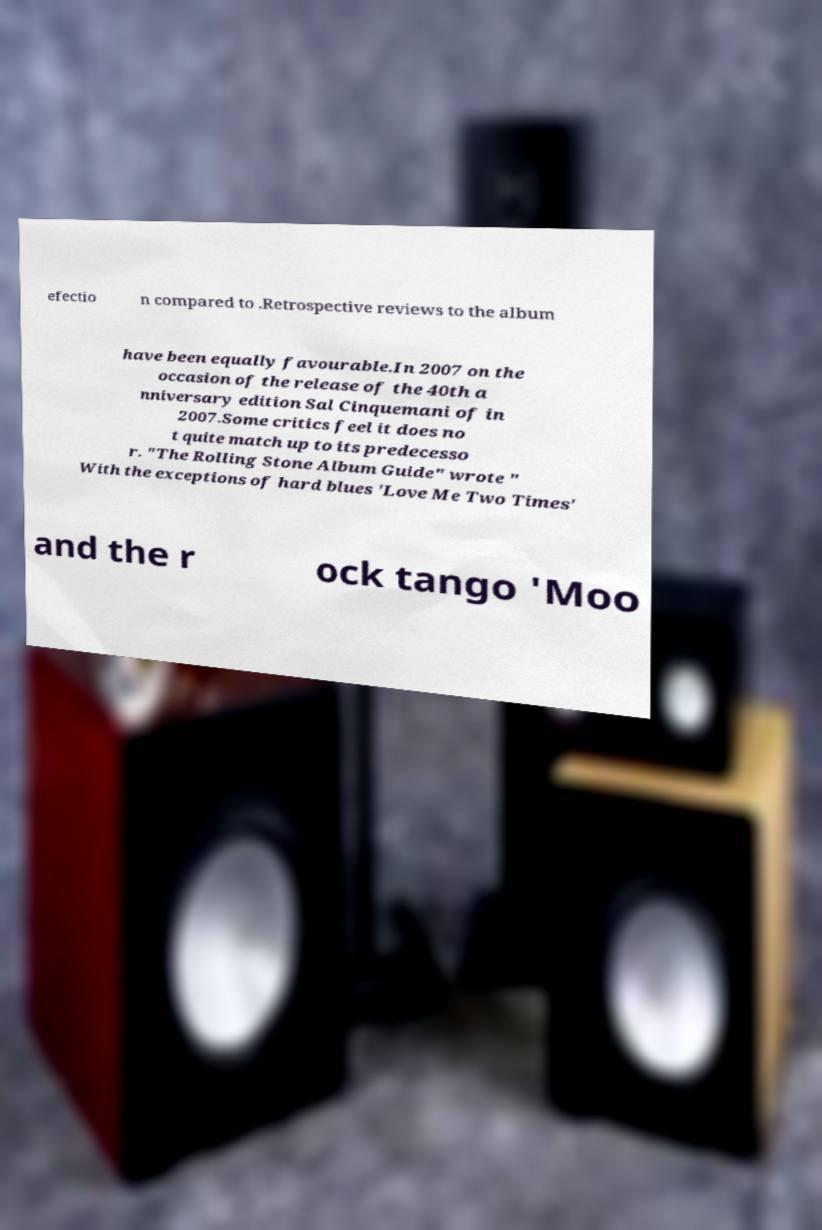Can you read and provide the text displayed in the image?This photo seems to have some interesting text. Can you extract and type it out for me? efectio n compared to .Retrospective reviews to the album have been equally favourable.In 2007 on the occasion of the release of the 40th a nniversary edition Sal Cinquemani of in 2007.Some critics feel it does no t quite match up to its predecesso r. "The Rolling Stone Album Guide" wrote " With the exceptions of hard blues 'Love Me Two Times' and the r ock tango 'Moo 